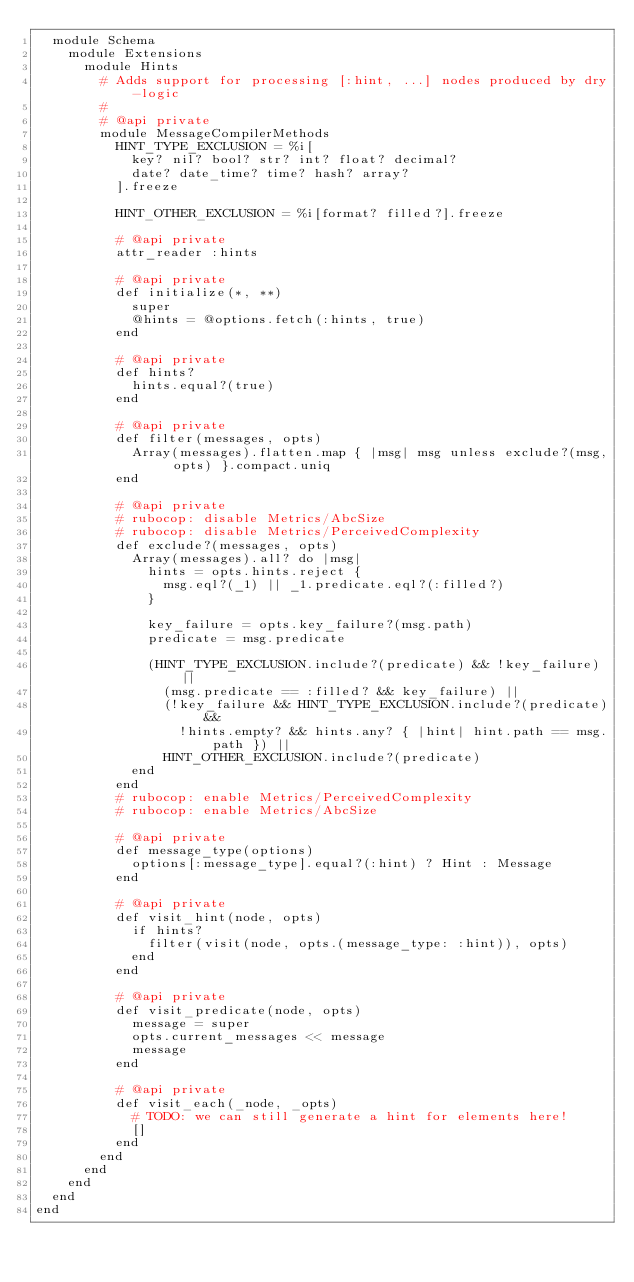<code> <loc_0><loc_0><loc_500><loc_500><_Ruby_>  module Schema
    module Extensions
      module Hints
        # Adds support for processing [:hint, ...] nodes produced by dry-logic
        #
        # @api private
        module MessageCompilerMethods
          HINT_TYPE_EXCLUSION = %i[
            key? nil? bool? str? int? float? decimal?
            date? date_time? time? hash? array?
          ].freeze

          HINT_OTHER_EXCLUSION = %i[format? filled?].freeze

          # @api private
          attr_reader :hints

          # @api private
          def initialize(*, **)
            super
            @hints = @options.fetch(:hints, true)
          end

          # @api private
          def hints?
            hints.equal?(true)
          end

          # @api private
          def filter(messages, opts)
            Array(messages).flatten.map { |msg| msg unless exclude?(msg, opts) }.compact.uniq
          end

          # @api private
          # rubocop: disable Metrics/AbcSize
          # rubocop: disable Metrics/PerceivedComplexity
          def exclude?(messages, opts)
            Array(messages).all? do |msg|
              hints = opts.hints.reject {
                msg.eql?(_1) || _1.predicate.eql?(:filled?)
              }

              key_failure = opts.key_failure?(msg.path)
              predicate = msg.predicate

              (HINT_TYPE_EXCLUSION.include?(predicate) && !key_failure) ||
                (msg.predicate == :filled? && key_failure) ||
                (!key_failure && HINT_TYPE_EXCLUSION.include?(predicate) &&
                  !hints.empty? && hints.any? { |hint| hint.path == msg.path }) ||
                HINT_OTHER_EXCLUSION.include?(predicate)
            end
          end
          # rubocop: enable Metrics/PerceivedComplexity
          # rubocop: enable Metrics/AbcSize

          # @api private
          def message_type(options)
            options[:message_type].equal?(:hint) ? Hint : Message
          end

          # @api private
          def visit_hint(node, opts)
            if hints?
              filter(visit(node, opts.(message_type: :hint)), opts)
            end
          end

          # @api private
          def visit_predicate(node, opts)
            message = super
            opts.current_messages << message
            message
          end

          # @api private
          def visit_each(_node, _opts)
            # TODO: we can still generate a hint for elements here!
            []
          end
        end
      end
    end
  end
end
</code> 